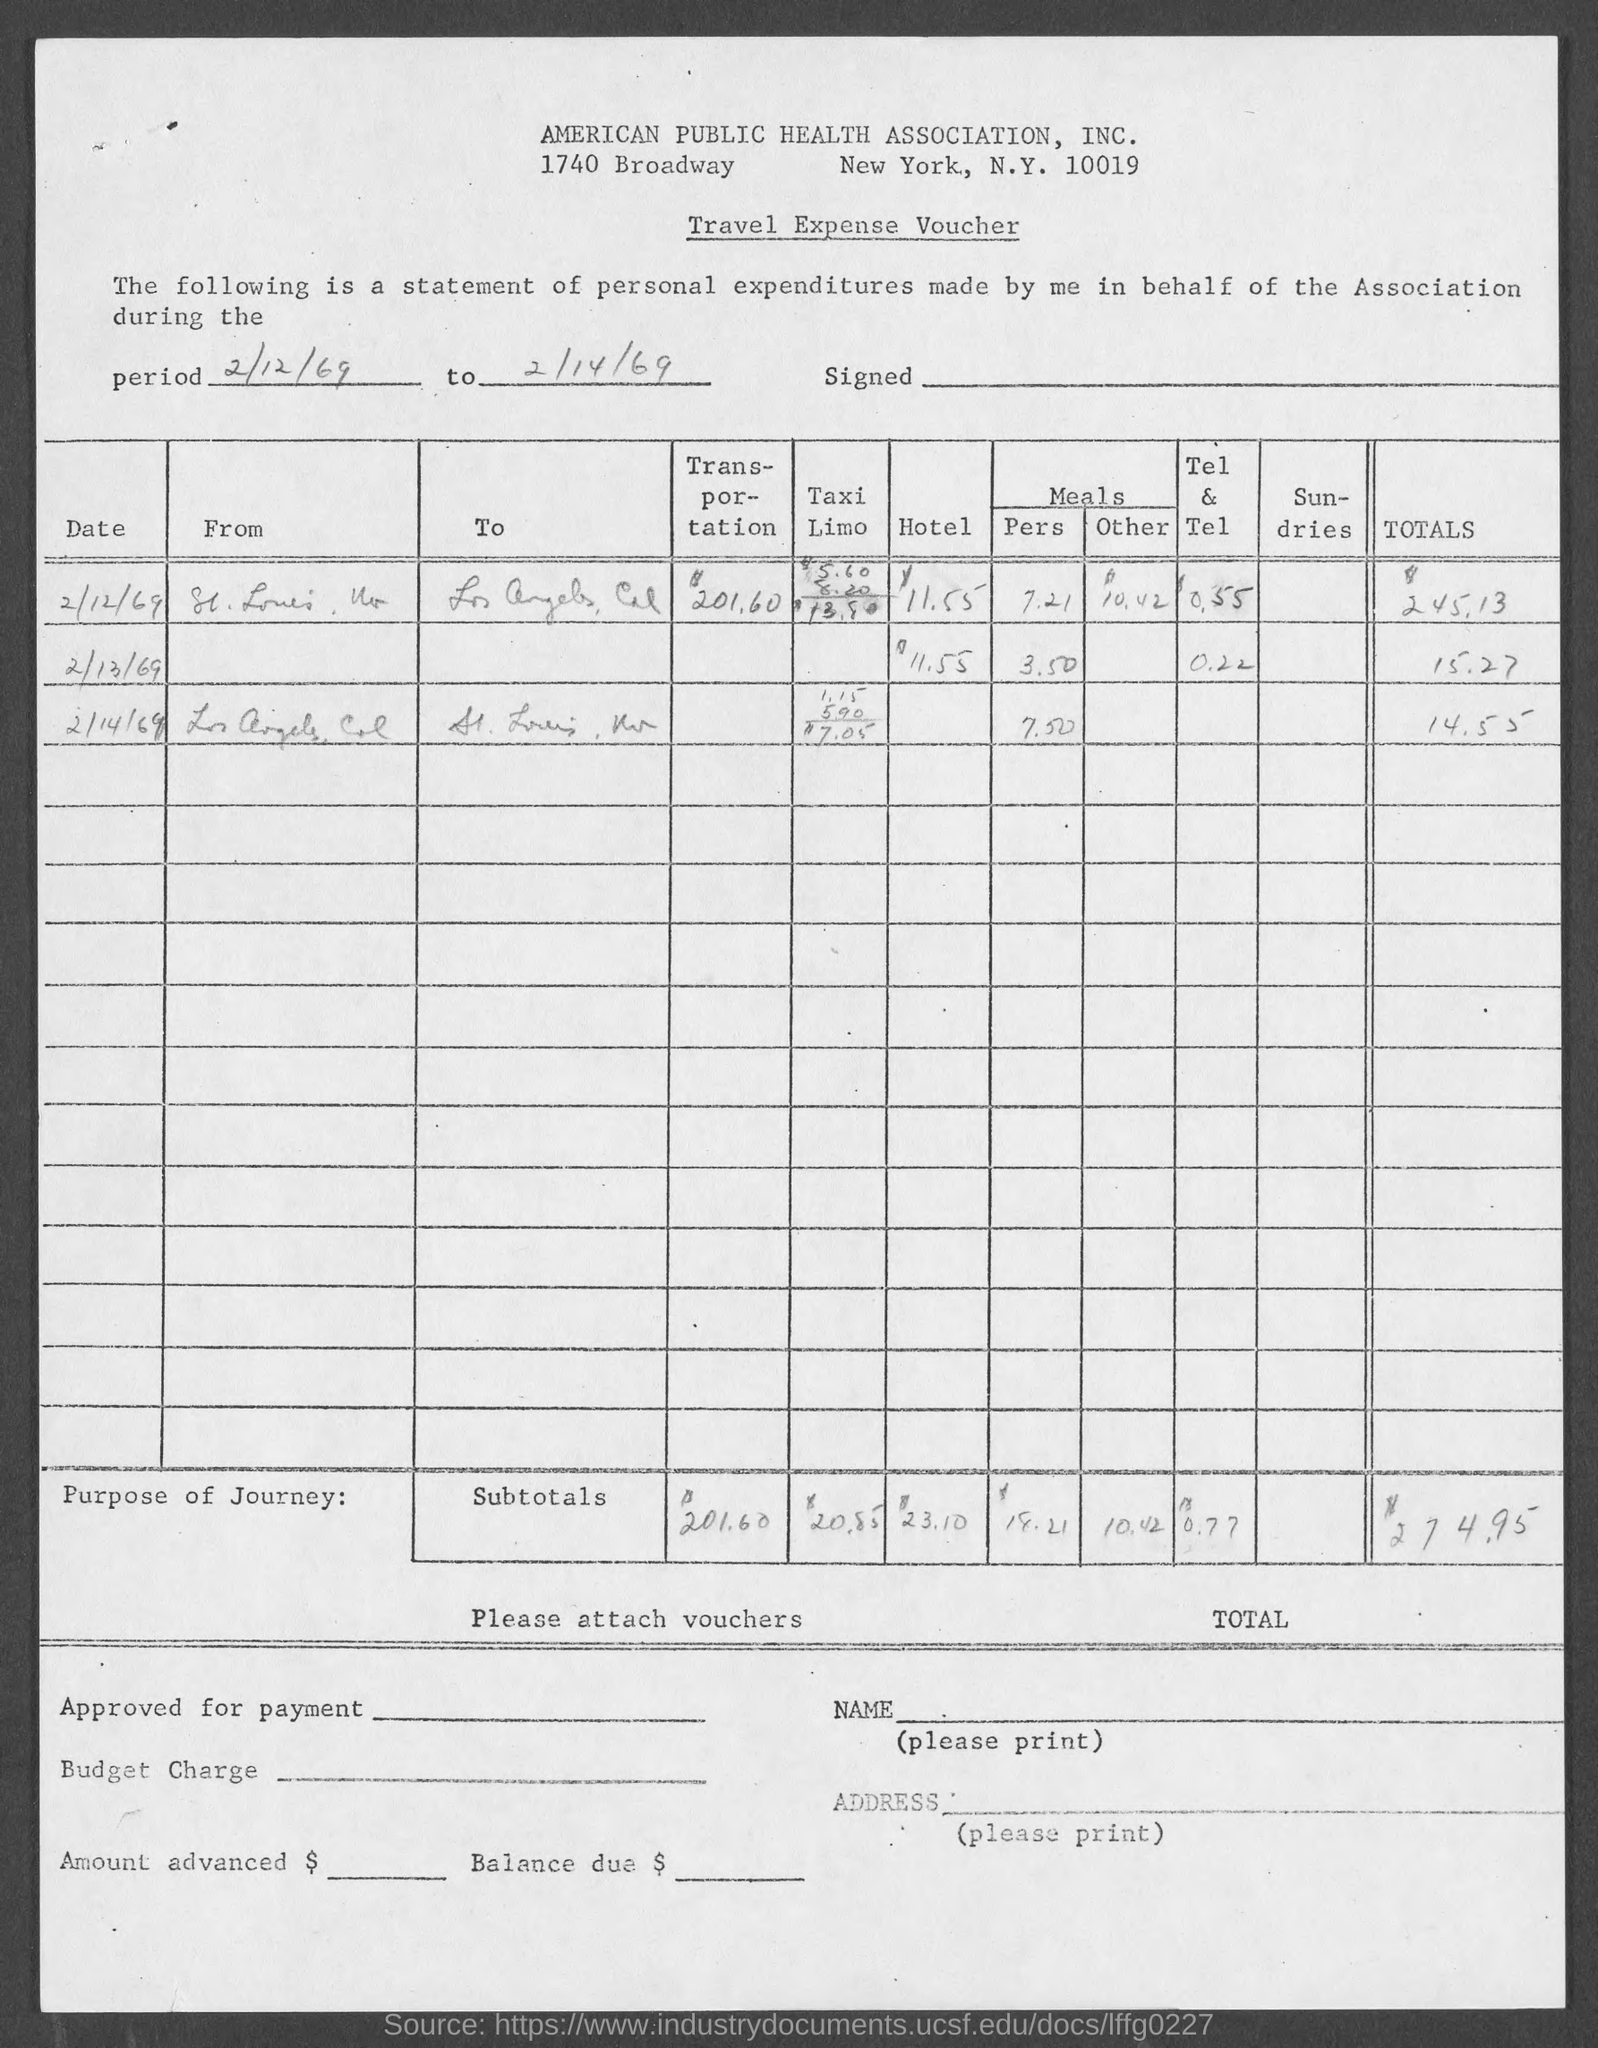Point out several critical features in this image. American Public Health Association, Inc. is located in New York City. 